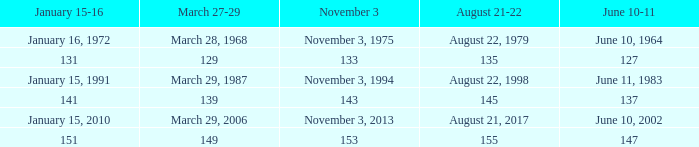What number is shown for november 3 where january 15-16 is 151? 153.0. Help me parse the entirety of this table. {'header': ['January 15-16', 'March 27-29', 'November 3', 'August 21-22', 'June 10-11'], 'rows': [['January 16, 1972', 'March 28, 1968', 'November 3, 1975', 'August 22, 1979', 'June 10, 1964'], ['131', '129', '133', '135', '127'], ['January 15, 1991', 'March 29, 1987', 'November 3, 1994', 'August 22, 1998', 'June 11, 1983'], ['141', '139', '143', '145', '137'], ['January 15, 2010', 'March 29, 2006', 'November 3, 2013', 'August 21, 2017', 'June 10, 2002'], ['151', '149', '153', '155', '147']]} 